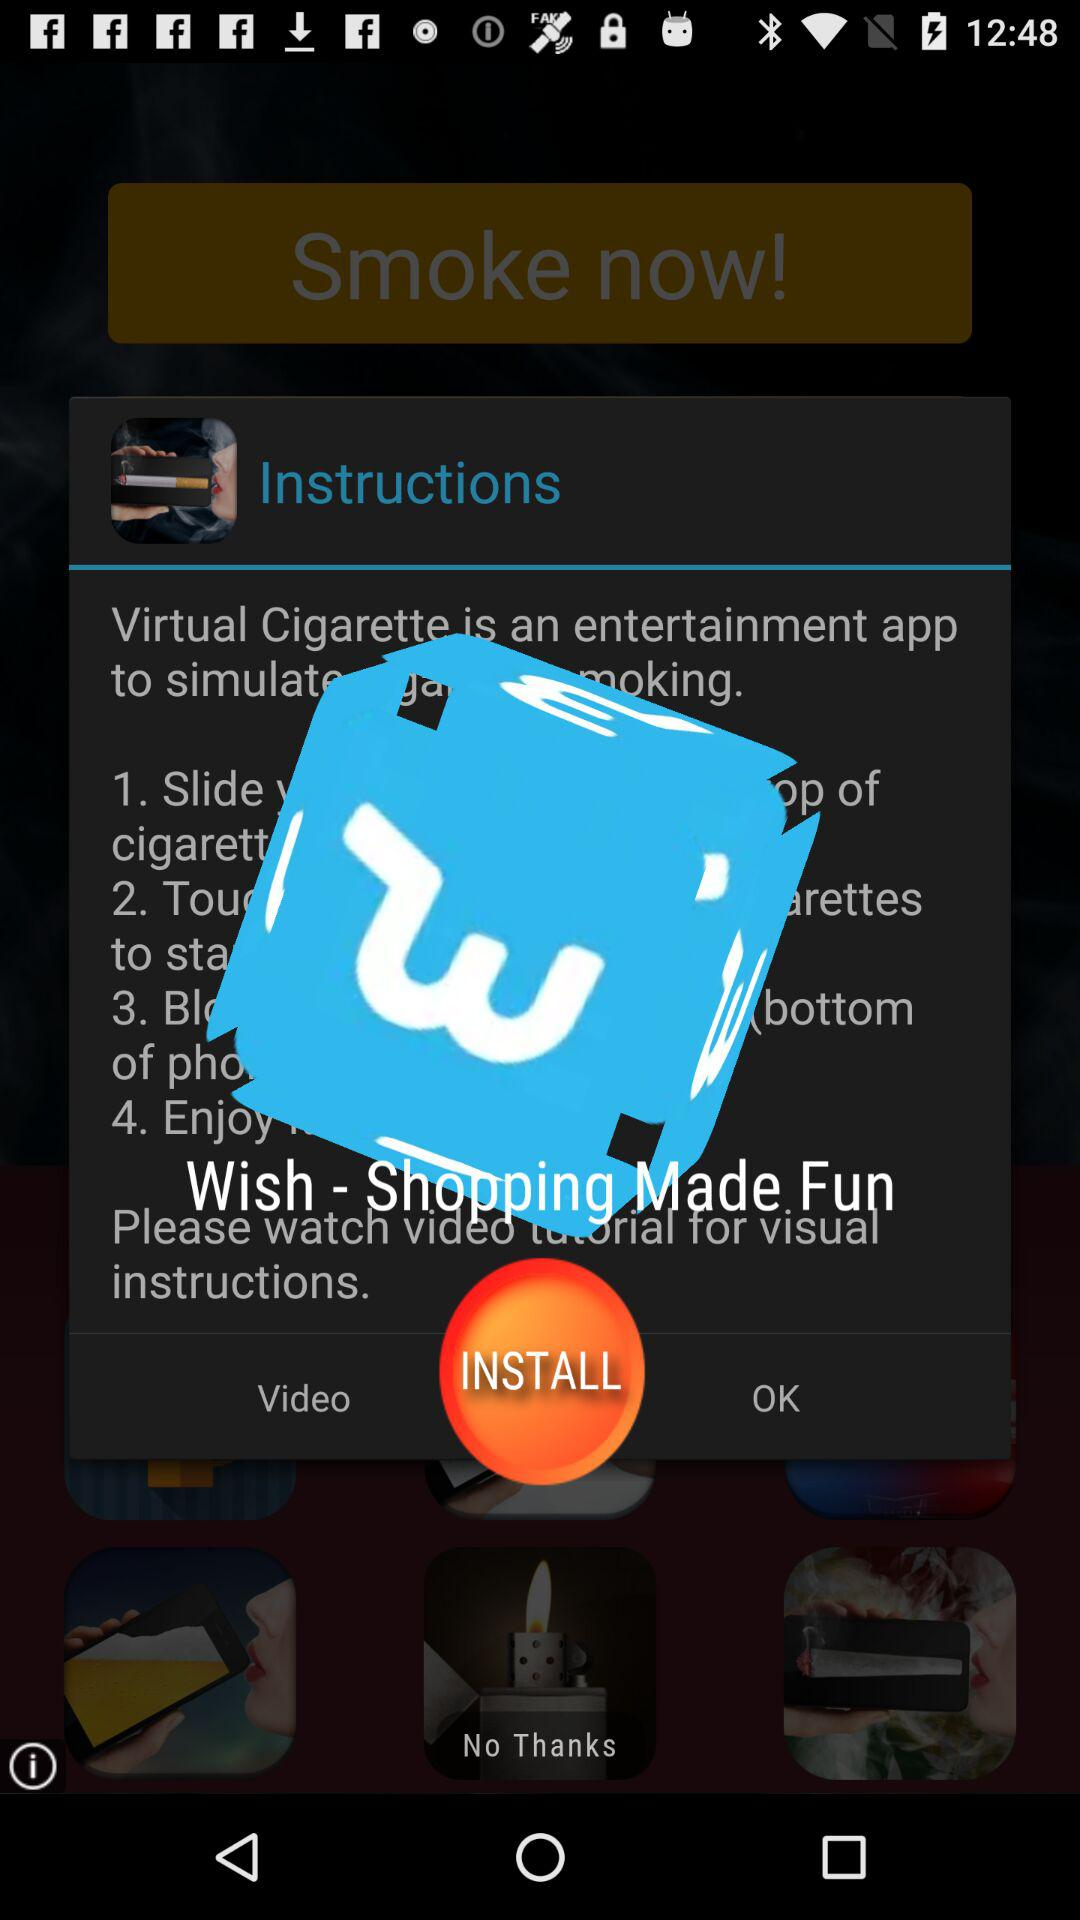What is the application name? The application names are "Virtual Cigarette" and "Wish - Shopping Made Fun". 